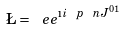<formula> <loc_0><loc_0><loc_500><loc_500>\L = \ e e ^ { \i i \ p \ n J ^ { 0 1 } }</formula> 